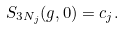Convert formula to latex. <formula><loc_0><loc_0><loc_500><loc_500>S _ { 3 N _ { j } } ( g , 0 ) = c _ { j } .</formula> 